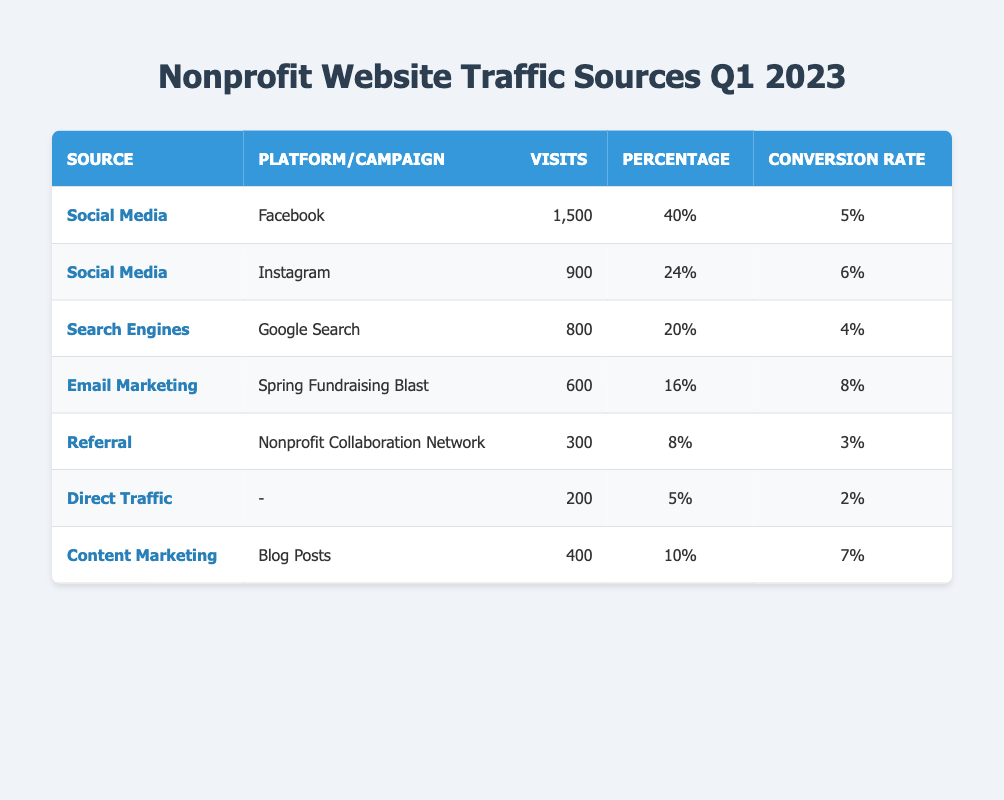What is the total number of visits from Social Media sources? From the table, the visits from Social Media are: Facebook (1,500) and Instagram (900). Adding these gives 1,500 + 900 = 2,400 visits from Social Media sources.
Answer: 2,400 Which traffic source had the highest conversion rate? Looking at the conversion rates in the table, Email Marketing (Spring Fundraising Blast) has the highest conversion rate of 8%.
Answer: Email Marketing What percentage of visits came from Search Engines? The table shows that the percentage of visits from Search Engines (Google Search) is 20%.
Answer: 20% Is the conversion rate from Direct Traffic higher than that from Referral? The conversion rate for Direct Traffic is 2%, while for Referral it is 3%. Since 2% is less than 3%, the statement is false.
Answer: No How many visits were generated by Content Marketing? The table indicates that Content Marketing (Blog Posts) generated 400 visits.
Answer: 400 What proportion of total visits came from Email Marketing? The total visits from all sources is 3,800 (1,500 + 900 + 800 + 600 + 300 + 200 + 400). Email Marketing generated 600 visits, so the proportion is 600 / 3,800 = 0.1579, or 15.79%.
Answer: 15.79% Which traffic source contributed the least visits? According to the table, Direct Traffic had the least visits at 200.
Answer: Direct Traffic What is the difference in conversion rates between the highest and the lowest sources? The highest conversion rate is from Email Marketing at 8%, and the lowest is from Direct Traffic at 2%. The difference is 8% - 2% = 6%.
Answer: 6% What is the average number of visits from Social Media platforms? The visits from Social Media platforms are 1,500 (Facebook) and 900 (Instagram). The average is (1,500 + 900) / 2 = 1,200.
Answer: 1,200 Did Referral traffic contribute more visits than Search Engines? Referral had 300 visits, while Search Engines had 800 visits. Since 300 is less than 800, the statement is false.
Answer: No 